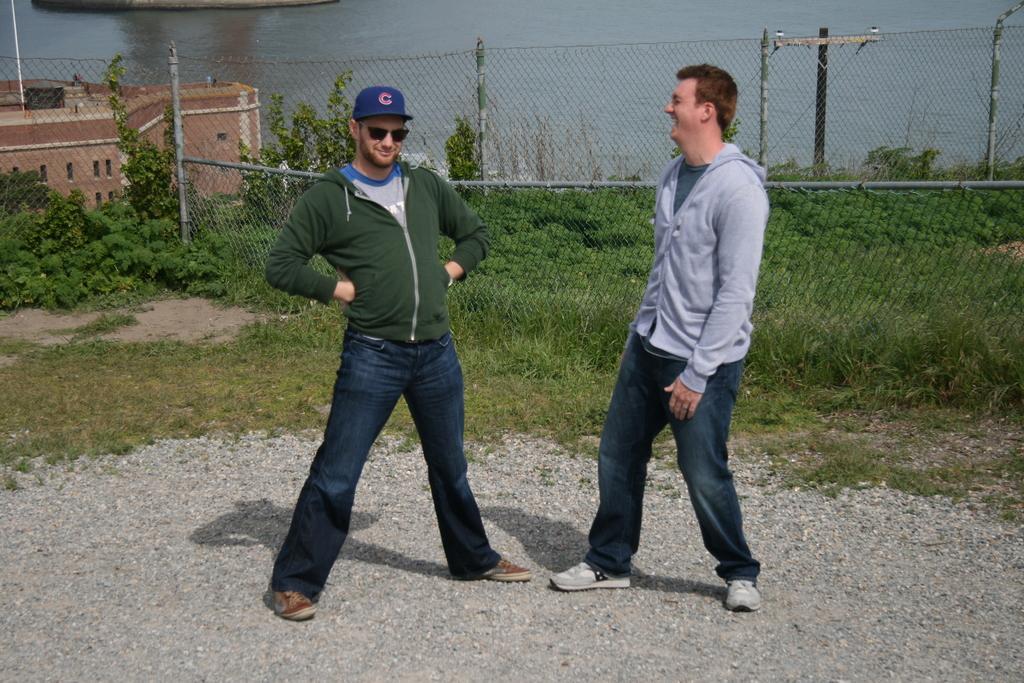In one or two sentences, can you explain what this image depicts? Here we can see two people. Background there are plants, fence, grass, building with windows and water. 